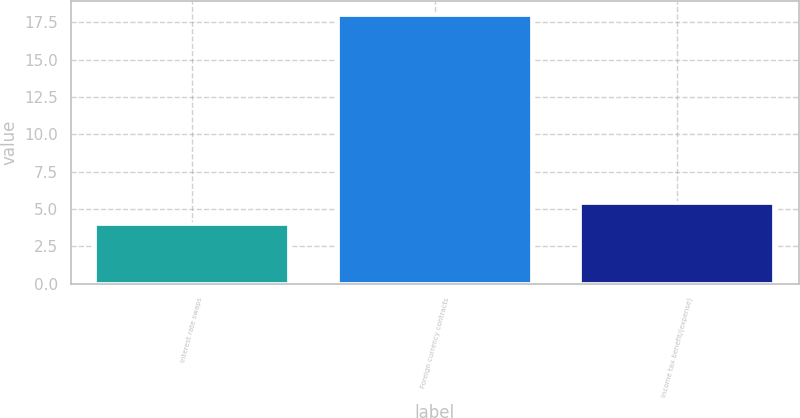Convert chart to OTSL. <chart><loc_0><loc_0><loc_500><loc_500><bar_chart><fcel>Interest rate swaps<fcel>Foreign currency contracts<fcel>Income tax benefit/(expense)<nl><fcel>4<fcel>18<fcel>5.4<nl></chart> 